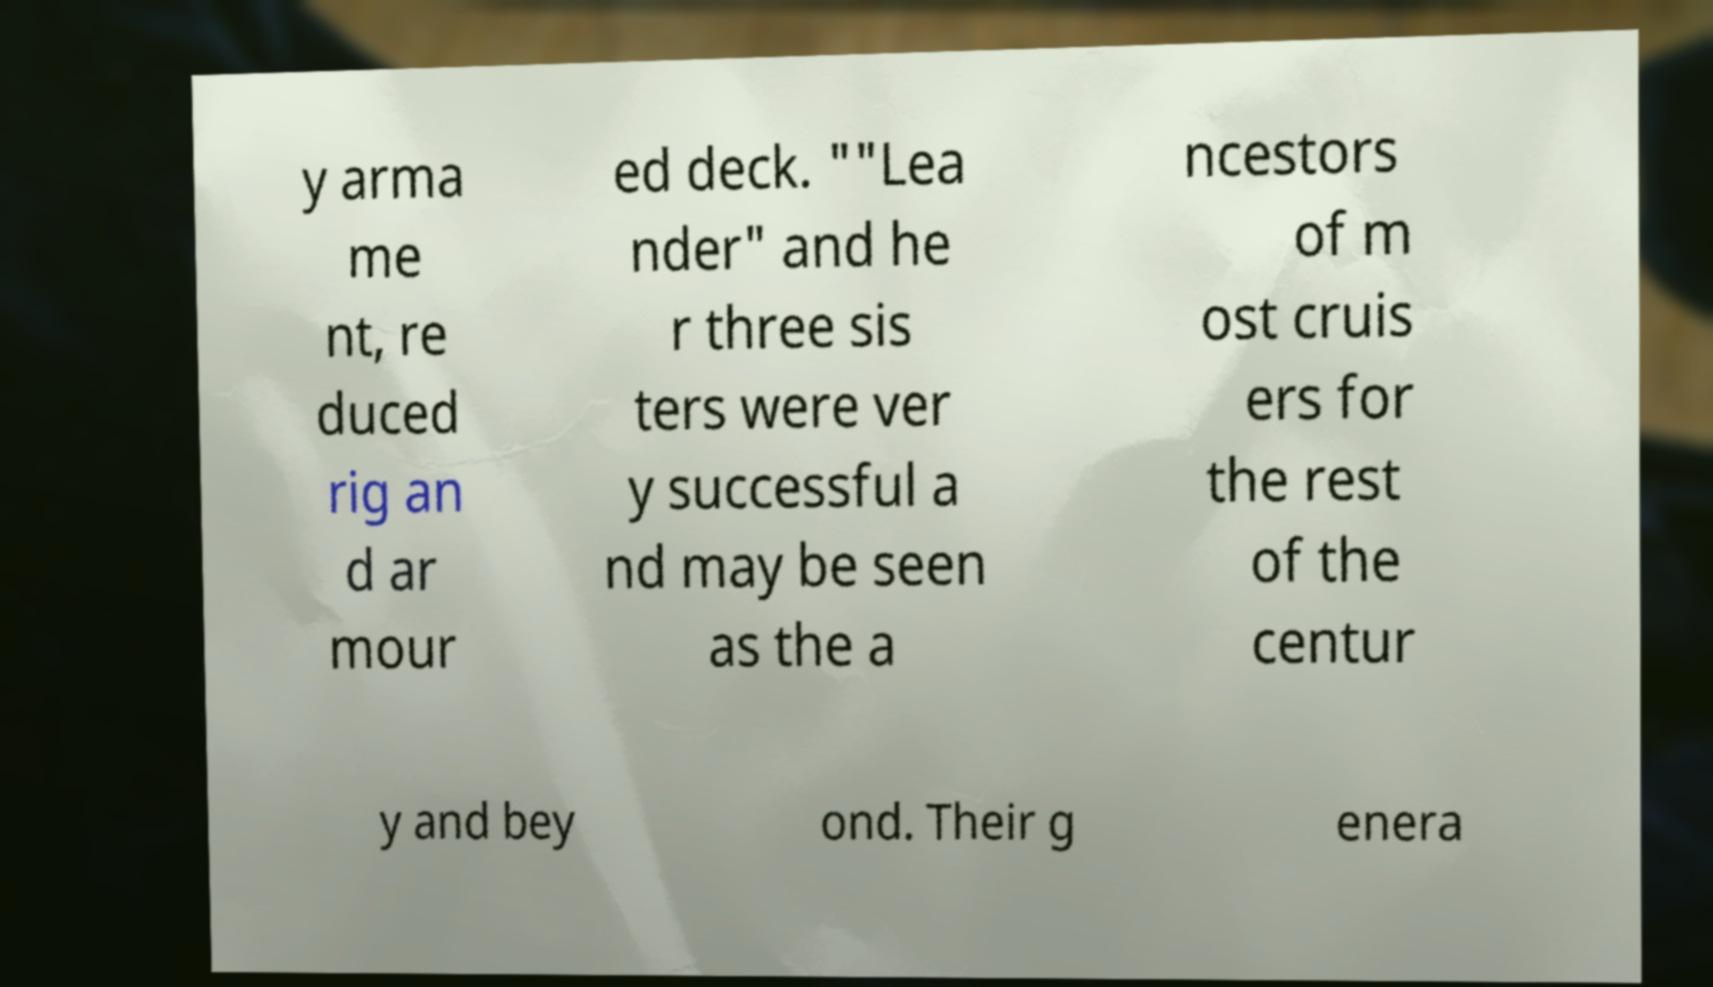I need the written content from this picture converted into text. Can you do that? y arma me nt, re duced rig an d ar mour ed deck. ""Lea nder" and he r three sis ters were ver y successful a nd may be seen as the a ncestors of m ost cruis ers for the rest of the centur y and bey ond. Their g enera 